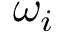Convert formula to latex. <formula><loc_0><loc_0><loc_500><loc_500>\omega _ { i }</formula> 